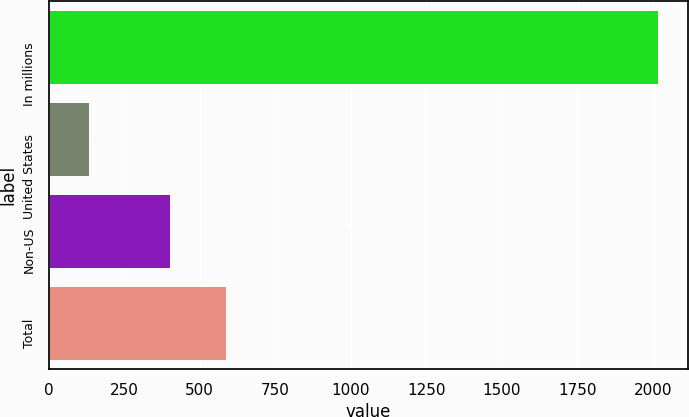Convert chart to OTSL. <chart><loc_0><loc_0><loc_500><loc_500><bar_chart><fcel>In millions<fcel>United States<fcel>Non-US<fcel>Total<nl><fcel>2015<fcel>134.9<fcel>400.2<fcel>588.21<nl></chart> 